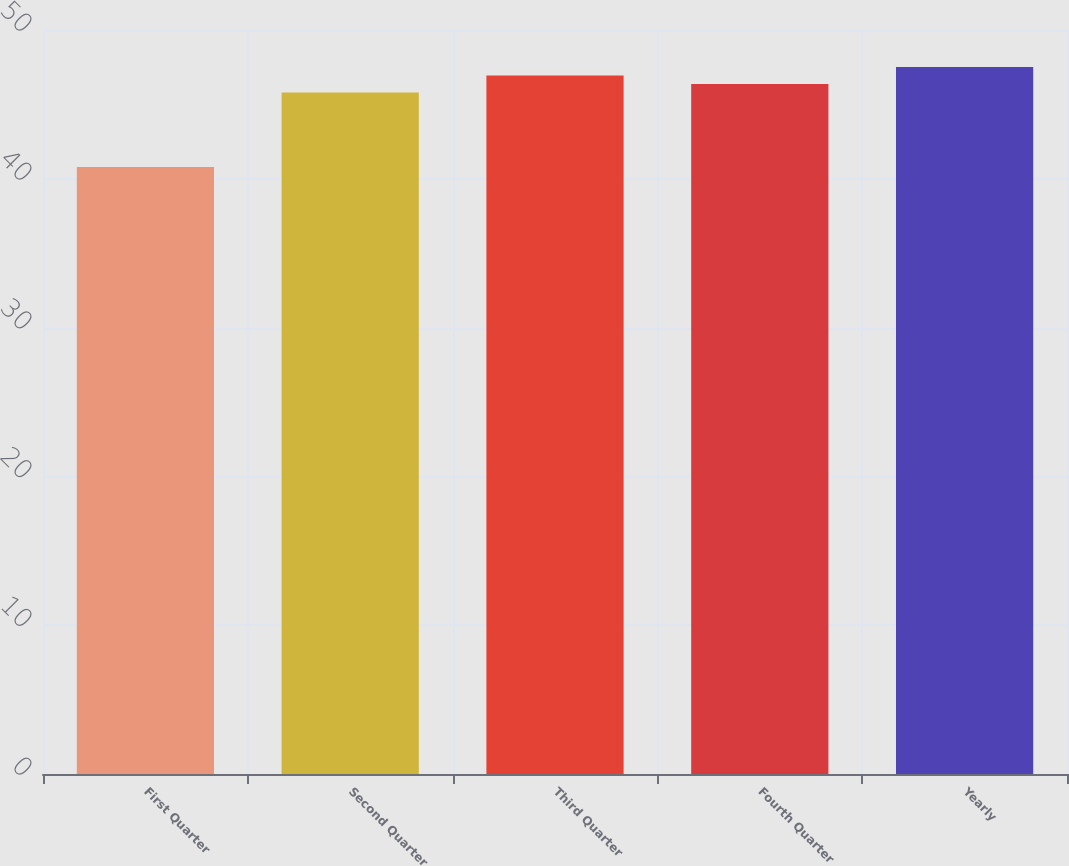Convert chart to OTSL. <chart><loc_0><loc_0><loc_500><loc_500><bar_chart><fcel>First Quarter<fcel>Second Quarter<fcel>Third Quarter<fcel>Fourth Quarter<fcel>Yearly<nl><fcel>40.8<fcel>45.8<fcel>46.94<fcel>46.37<fcel>47.51<nl></chart> 